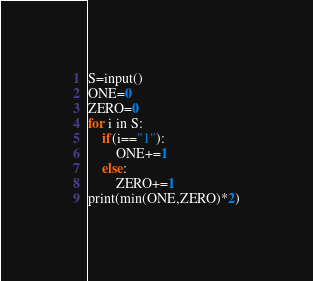<code> <loc_0><loc_0><loc_500><loc_500><_Python_>S=input()
ONE=0
ZERO=0
for i in S:
    if(i=="1"):
        ONE+=1
    else:
        ZERO+=1
print(min(ONE,ZERO)*2)
</code> 